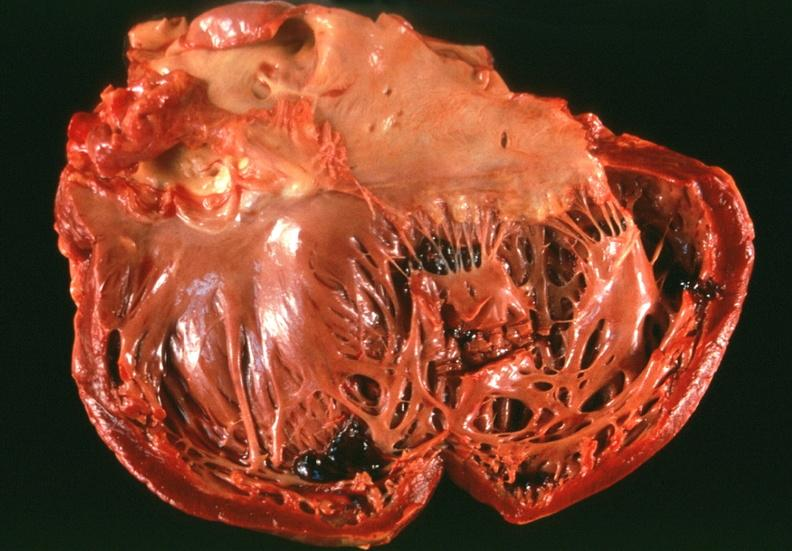what is present?
Answer the question using a single word or phrase. Cardiovascular 